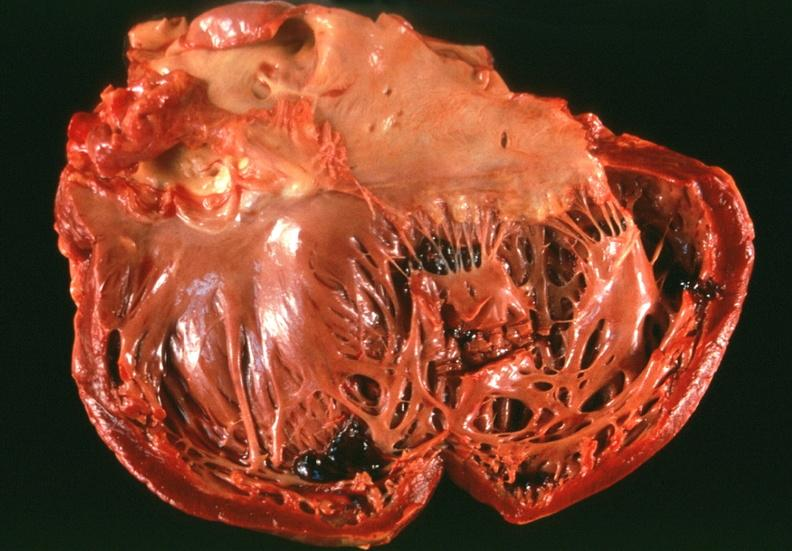what is present?
Answer the question using a single word or phrase. Cardiovascular 